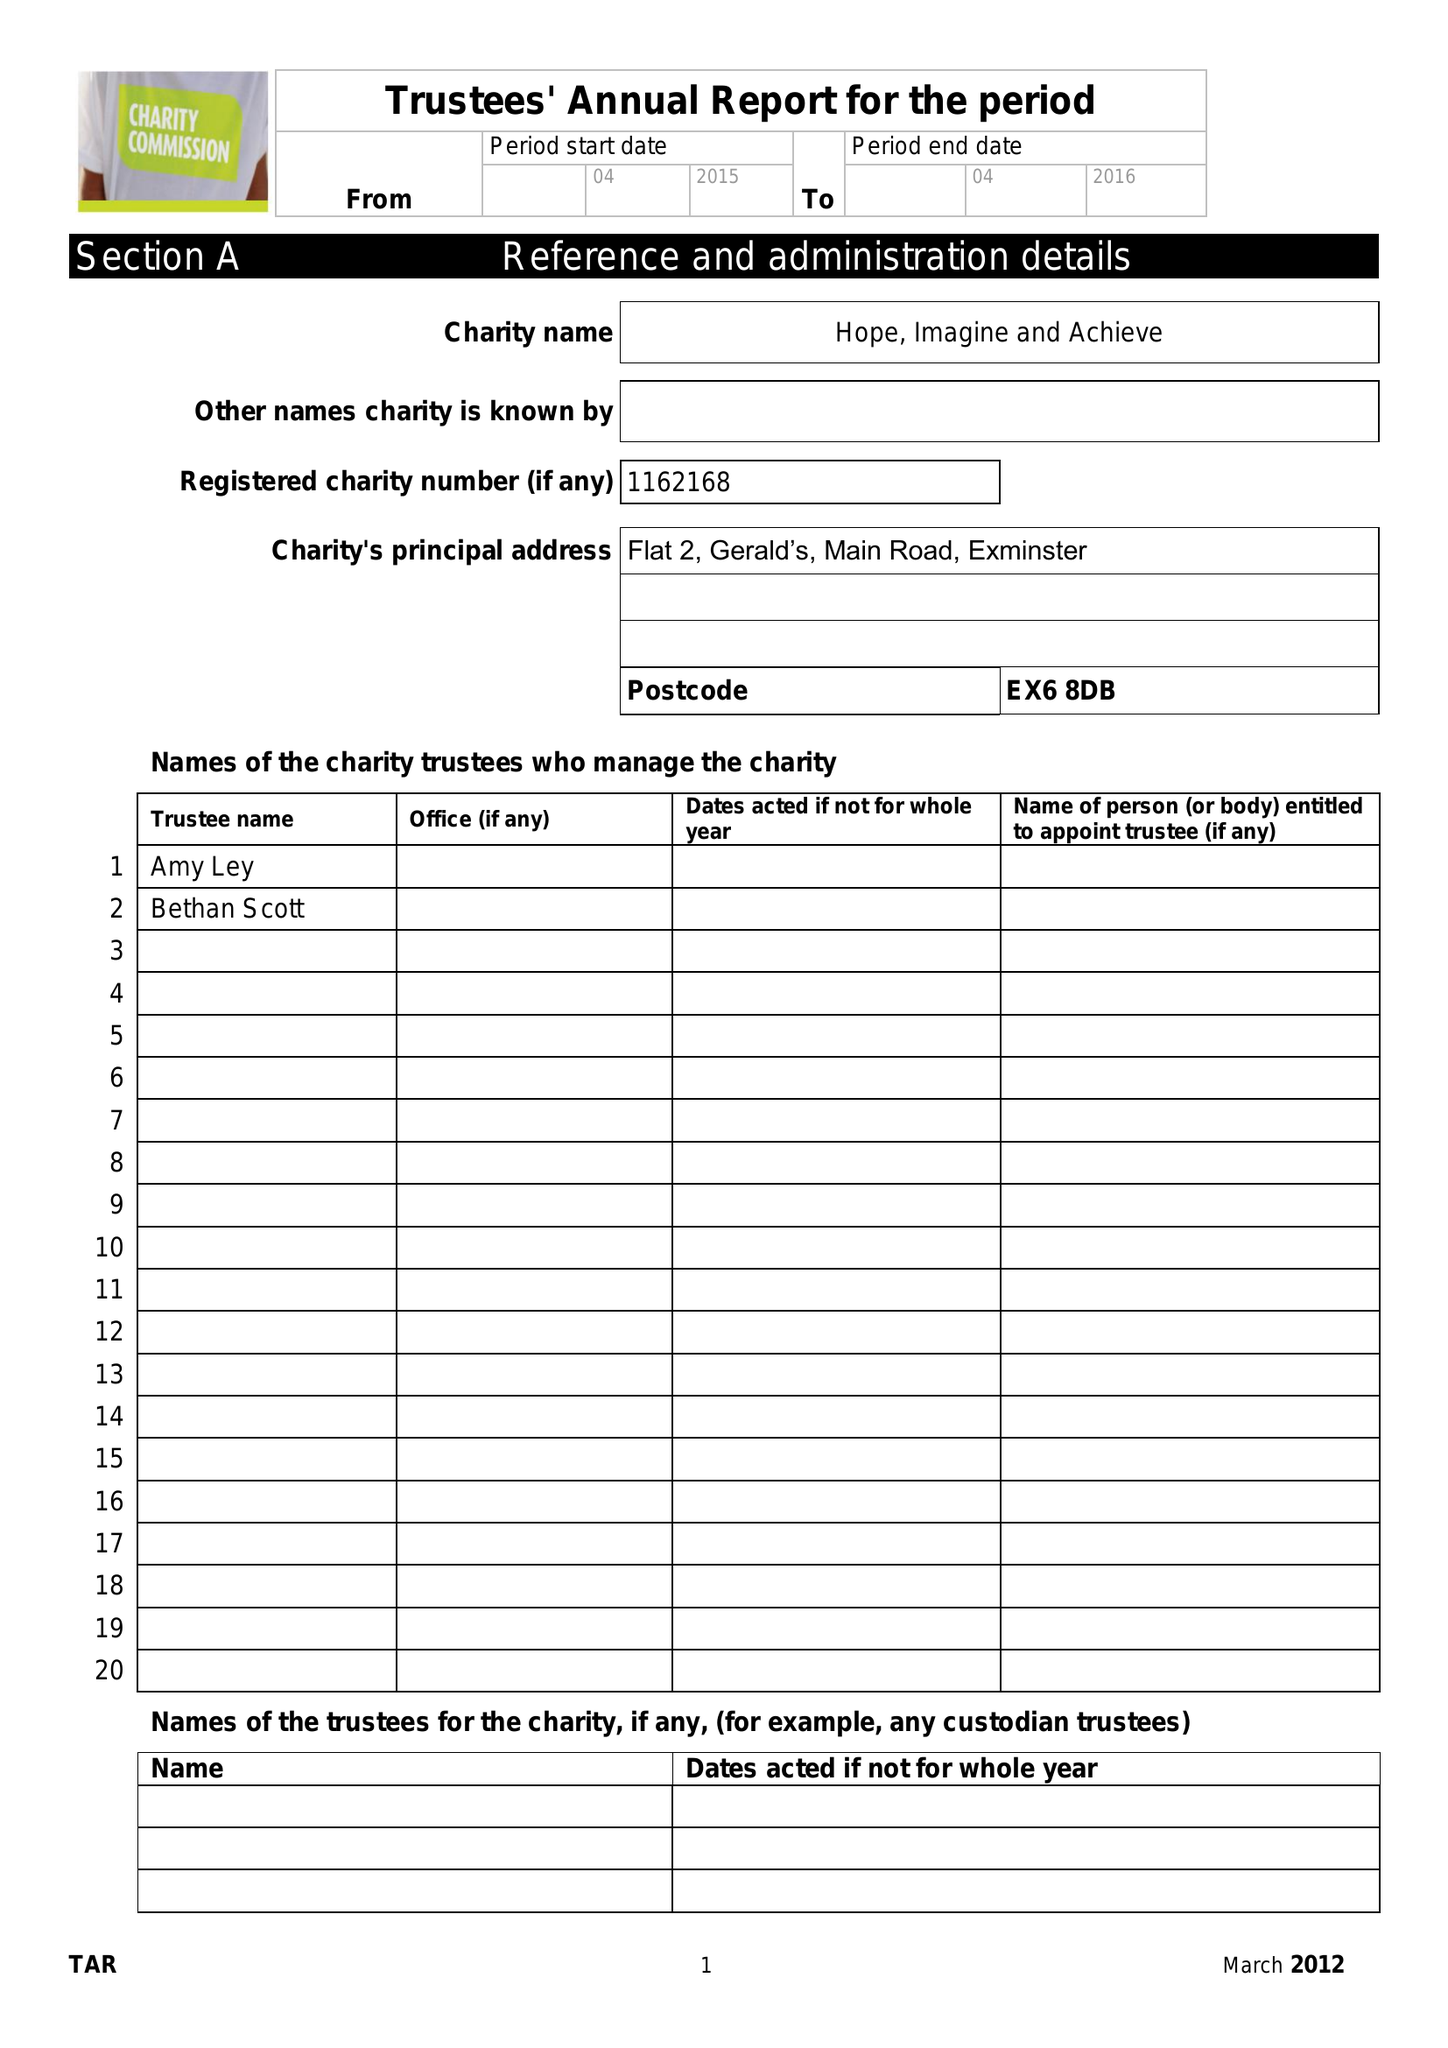What is the value for the address__post_town?
Answer the question using a single word or phrase. EXETER 